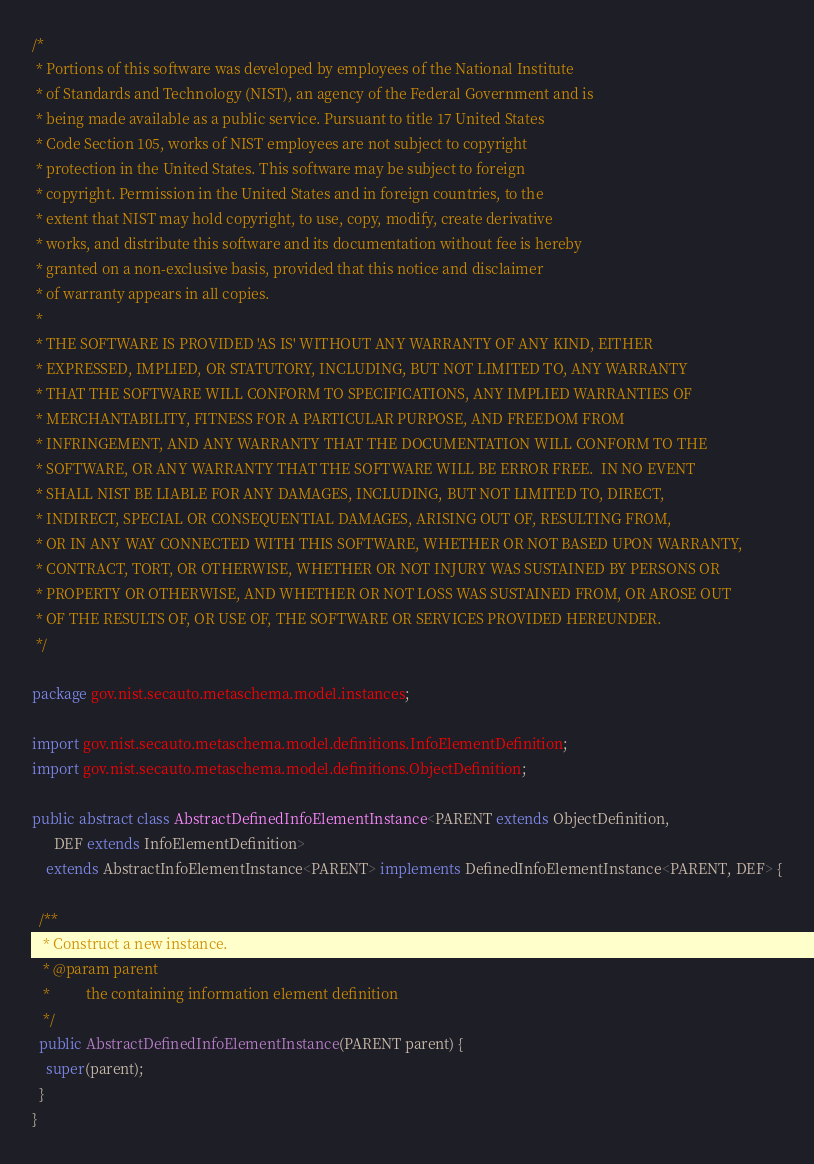Convert code to text. <code><loc_0><loc_0><loc_500><loc_500><_Java_>/*
 * Portions of this software was developed by employees of the National Institute
 * of Standards and Technology (NIST), an agency of the Federal Government and is
 * being made available as a public service. Pursuant to title 17 United States
 * Code Section 105, works of NIST employees are not subject to copyright
 * protection in the United States. This software may be subject to foreign
 * copyright. Permission in the United States and in foreign countries, to the
 * extent that NIST may hold copyright, to use, copy, modify, create derivative
 * works, and distribute this software and its documentation without fee is hereby
 * granted on a non-exclusive basis, provided that this notice and disclaimer
 * of warranty appears in all copies.
 *
 * THE SOFTWARE IS PROVIDED 'AS IS' WITHOUT ANY WARRANTY OF ANY KIND, EITHER
 * EXPRESSED, IMPLIED, OR STATUTORY, INCLUDING, BUT NOT LIMITED TO, ANY WARRANTY
 * THAT THE SOFTWARE WILL CONFORM TO SPECIFICATIONS, ANY IMPLIED WARRANTIES OF
 * MERCHANTABILITY, FITNESS FOR A PARTICULAR PURPOSE, AND FREEDOM FROM
 * INFRINGEMENT, AND ANY WARRANTY THAT THE DOCUMENTATION WILL CONFORM TO THE
 * SOFTWARE, OR ANY WARRANTY THAT THE SOFTWARE WILL BE ERROR FREE.  IN NO EVENT
 * SHALL NIST BE LIABLE FOR ANY DAMAGES, INCLUDING, BUT NOT LIMITED TO, DIRECT,
 * INDIRECT, SPECIAL OR CONSEQUENTIAL DAMAGES, ARISING OUT OF, RESULTING FROM,
 * OR IN ANY WAY CONNECTED WITH THIS SOFTWARE, WHETHER OR NOT BASED UPON WARRANTY,
 * CONTRACT, TORT, OR OTHERWISE, WHETHER OR NOT INJURY WAS SUSTAINED BY PERSONS OR
 * PROPERTY OR OTHERWISE, AND WHETHER OR NOT LOSS WAS SUSTAINED FROM, OR AROSE OUT
 * OF THE RESULTS OF, OR USE OF, THE SOFTWARE OR SERVICES PROVIDED HEREUNDER.
 */

package gov.nist.secauto.metaschema.model.instances;

import gov.nist.secauto.metaschema.model.definitions.InfoElementDefinition;
import gov.nist.secauto.metaschema.model.definitions.ObjectDefinition;

public abstract class AbstractDefinedInfoElementInstance<PARENT extends ObjectDefinition,
      DEF extends InfoElementDefinition>
    extends AbstractInfoElementInstance<PARENT> implements DefinedInfoElementInstance<PARENT, DEF> {

  /**
   * Construct a new instance.
   * @param parent
   *          the containing information element definition
   */
  public AbstractDefinedInfoElementInstance(PARENT parent) {
    super(parent);
  }
}
</code> 